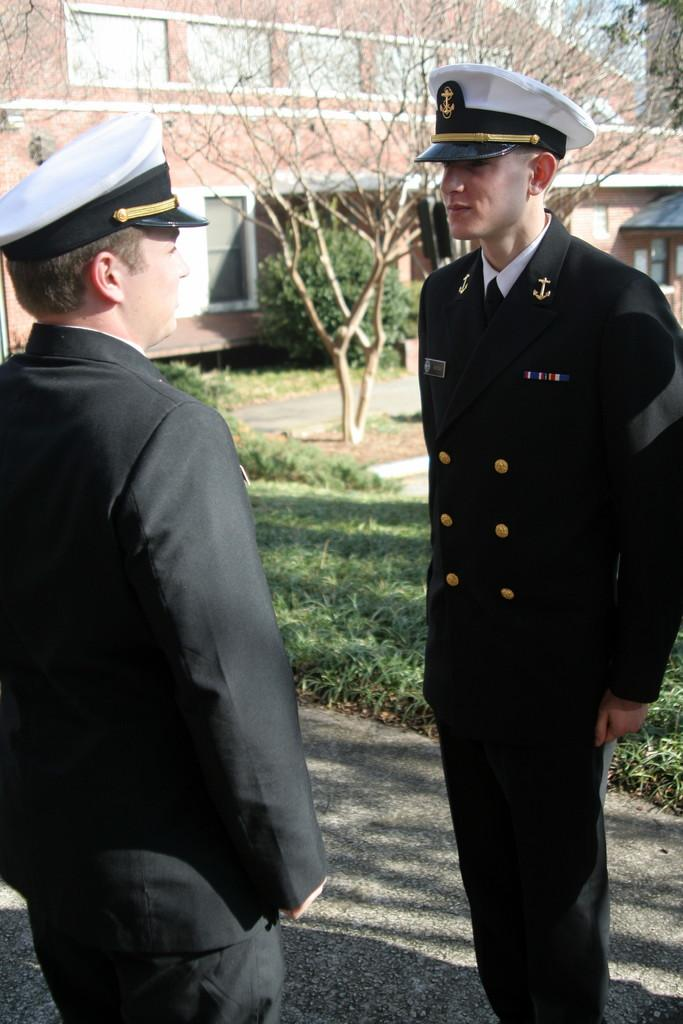How many people are in the image? There are two persons standing in the image. What can be seen in the image besides the people? There is a plant, grass, a tree, and a house in the background of the image. What are the people wearing on their heads? The two persons are wearing caps. What type of flag is being waved by the thumb in the image? There is no flag or thumb present in the image. How many copies of the plant are visible in the image? There is only one plant visible in the image. 